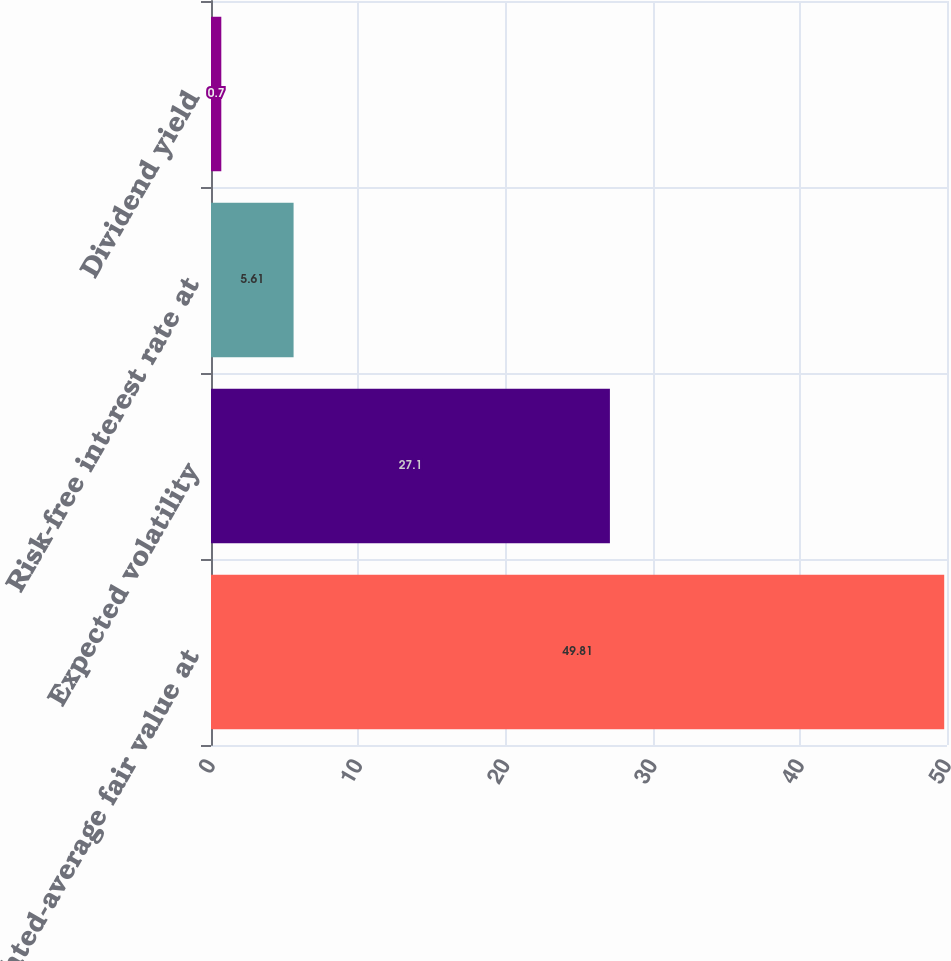<chart> <loc_0><loc_0><loc_500><loc_500><bar_chart><fcel>Weighted-average fair value at<fcel>Expected volatility<fcel>Risk-free interest rate at<fcel>Dividend yield<nl><fcel>49.81<fcel>27.1<fcel>5.61<fcel>0.7<nl></chart> 